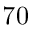Convert formula to latex. <formula><loc_0><loc_0><loc_500><loc_500>7 0</formula> 